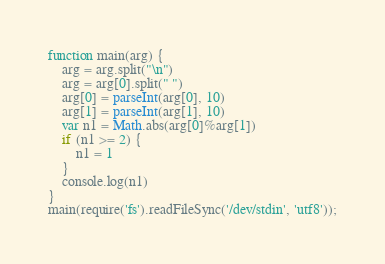<code> <loc_0><loc_0><loc_500><loc_500><_JavaScript_>function main(arg) {
    arg = arg.split("\n")
    arg = arg[0].split(" ")
    arg[0] = parseInt(arg[0], 10)
    arg[1] = parseInt(arg[1], 10)
    var n1 = Math.abs(arg[0]%arg[1])
    if (n1 >= 2) {
        n1 = 1
    }
    console.log(n1)
}
main(require('fs').readFileSync('/dev/stdin', 'utf8'));</code> 